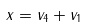Convert formula to latex. <formula><loc_0><loc_0><loc_500><loc_500>x = v _ { 4 } + v _ { 1 }</formula> 